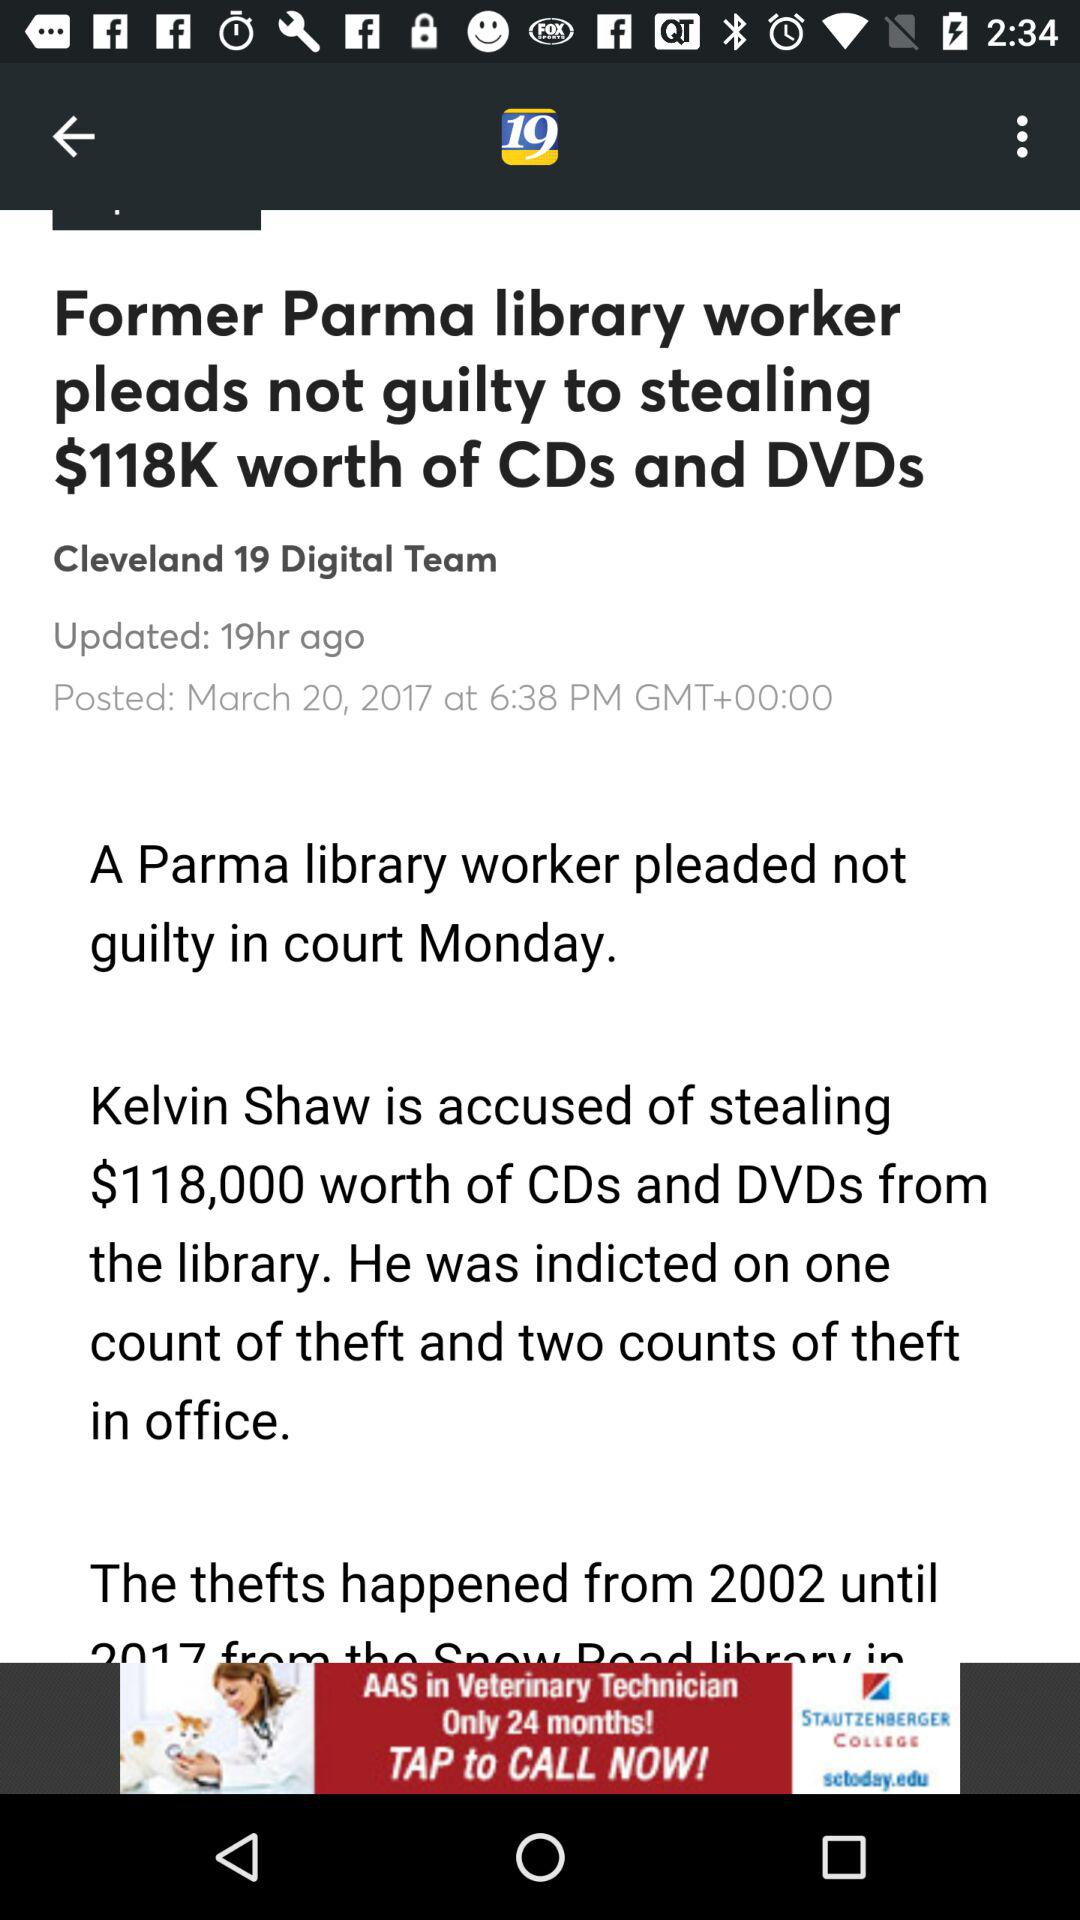What is the article name? The article name is "Former Parma library worker pleads not guilty to stealing $118K worth of CDs and DVDs". 